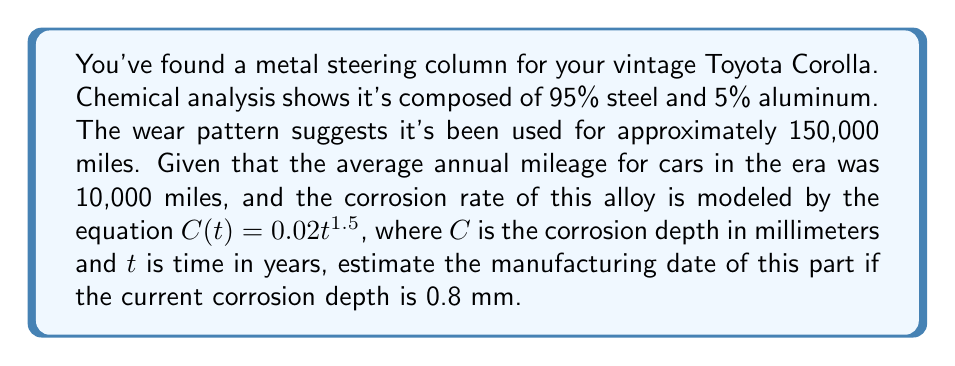Solve this math problem. To solve this inverse problem, we'll follow these steps:

1) First, let's determine how many years the part has been in use:
   $\text{Years of use} = \frac{\text{Total miles driven}}{\text{Average annual mileage}}$
   $= \frac{150,000}{10,000} = 15 \text{ years}$

2) Now, we need to solve the corrosion equation for $t$:
   $C(t) = 0.02t^{1.5}$
   $0.8 = 0.02t^{1.5}$

3) Solving for $t$:
   $t^{1.5} = \frac{0.8}{0.02} = 40$
   $t = 40^{\frac{2}{3}} \approx 11.7 \text{ years}$

4) This means the corrosion took 11.7 years to reach its current state.

5) To find the manufacturing date, we need to subtract both the years of use and the years of corrosion from the current year:
   $\text{Manufacturing year} = \text{Current year} - \text{Years of use} - \text{Years of corrosion}$
   $= 2023 - 15 - 11.7 \approx 1996$

Therefore, we estimate that the steering column was manufactured around 1996.
Answer: 1996 